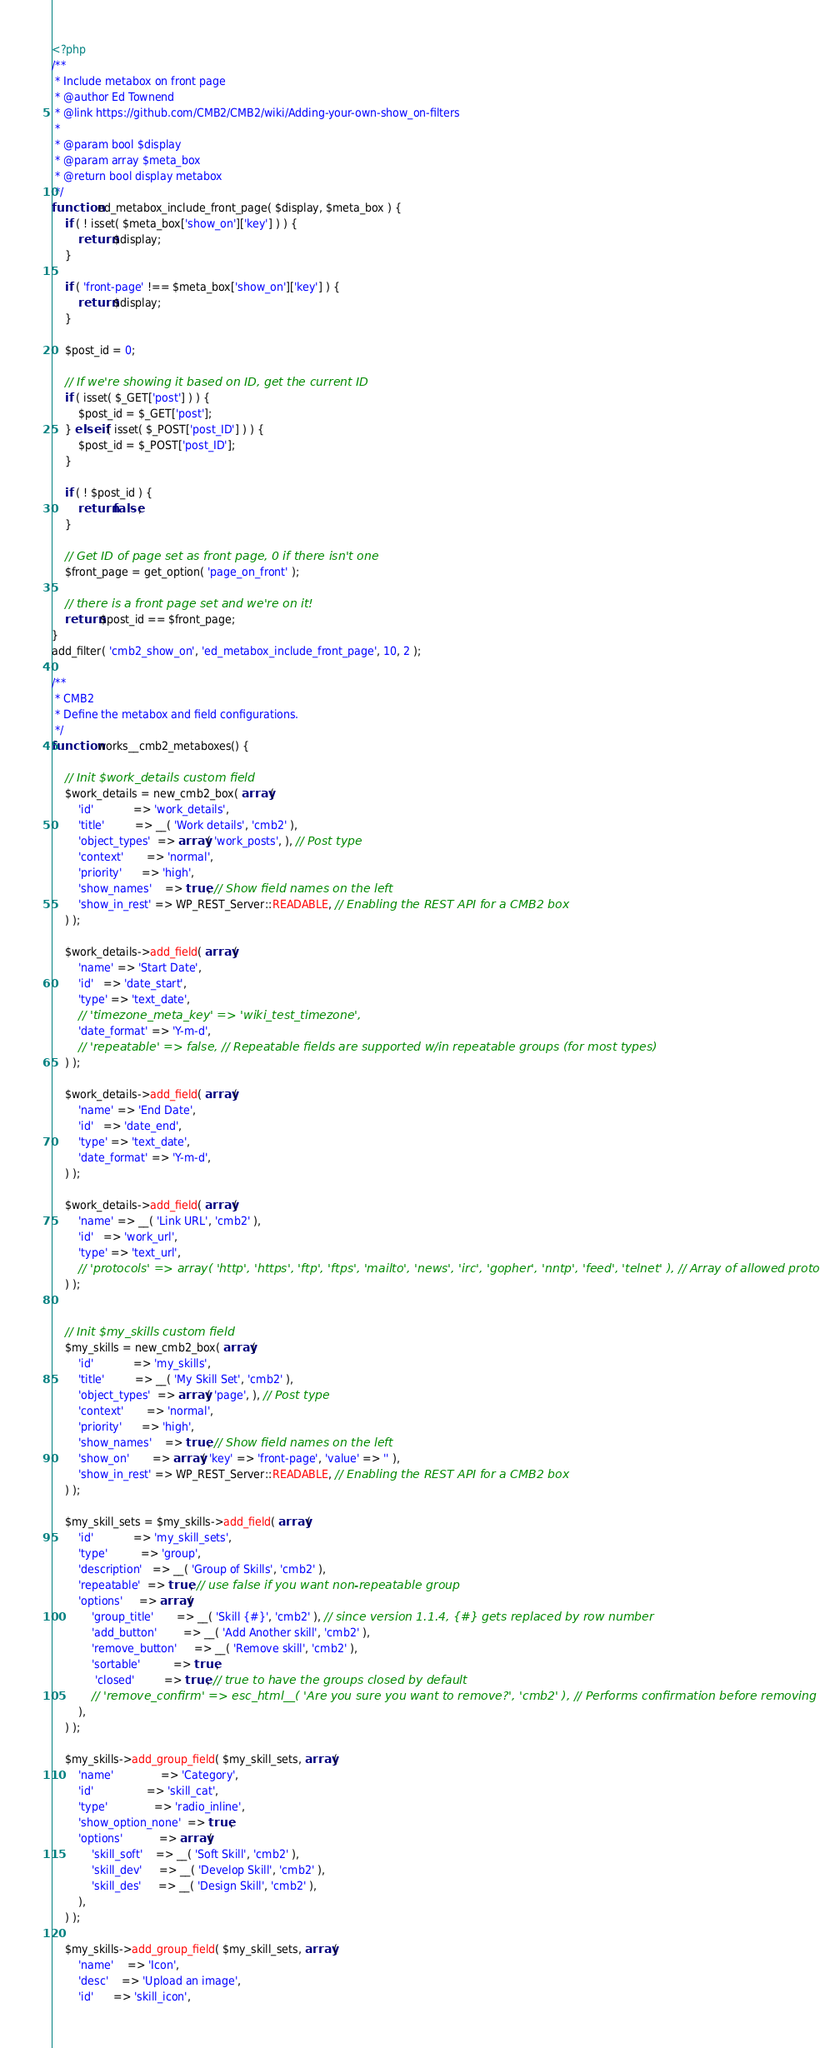<code> <loc_0><loc_0><loc_500><loc_500><_PHP_><?php
/**
 * Include metabox on front page
 * @author Ed Townend
 * @link https://github.com/CMB2/CMB2/wiki/Adding-your-own-show_on-filters
 *
 * @param bool $display
 * @param array $meta_box
 * @return bool display metabox
 */
function ed_metabox_include_front_page( $display, $meta_box ) {
	if ( ! isset( $meta_box['show_on']['key'] ) ) {
		return $display;
	}

	if ( 'front-page' !== $meta_box['show_on']['key'] ) {
		return $display;
	}

	$post_id = 0;

	// If we're showing it based on ID, get the current ID
	if ( isset( $_GET['post'] ) ) {
		$post_id = $_GET['post'];
	} elseif ( isset( $_POST['post_ID'] ) ) {
		$post_id = $_POST['post_ID'];
	}

	if ( ! $post_id ) {
		return false;
	}

	// Get ID of page set as front page, 0 if there isn't one
	$front_page = get_option( 'page_on_front' );

	// there is a front page set and we're on it!
	return $post_id == $front_page;
}
add_filter( 'cmb2_show_on', 'ed_metabox_include_front_page', 10, 2 );

/**
 * CMB2
 * Define the metabox and field configurations.
 */
function works__cmb2_metaboxes() {

	// Init $work_details custom field
	$work_details = new_cmb2_box( array(
		'id'            => 'work_details',
		'title'         => __( 'Work details', 'cmb2' ),
		'object_types'  => array( 'work_posts', ), // Post type
		'context'       => 'normal',
		'priority'      => 'high',
		'show_names'    => true, // Show field names on the left
		'show_in_rest' => WP_REST_Server::READABLE, // Enabling the REST API for a CMB2 box
	) );

	$work_details->add_field( array(
		'name' => 'Start Date',
		'id'   => 'date_start',
		'type' => 'text_date',
		// 'timezone_meta_key' => 'wiki_test_timezone',
		'date_format' => 'Y-m-d',
		// 'repeatable' => false, // Repeatable fields are supported w/in repeatable groups (for most types)
	) );

	$work_details->add_field( array(
		'name' => 'End Date',
		'id'   => 'date_end',
		'type' => 'text_date',
		'date_format' => 'Y-m-d',
	) );

	$work_details->add_field( array(
		'name' => __( 'Link URL', 'cmb2' ),
		'id'   => 'work_url',
		'type' => 'text_url',
		// 'protocols' => array( 'http', 'https', 'ftp', 'ftps', 'mailto', 'news', 'irc', 'gopher', 'nntp', 'feed', 'telnet' ), // Array of allowed protocols
	) );


	// Init $my_skills custom field
	$my_skills = new_cmb2_box( array(
		'id'            => 'my_skills',
		'title'         => __( 'My Skill Set', 'cmb2' ),
		'object_types'  => array( 'page', ), // Post type
		'context'       => 'normal',
		'priority'      => 'high',
		'show_names'    => true, // Show field names on the left
		'show_on'       => array( 'key' => 'front-page', 'value' => '' ),
		'show_in_rest' => WP_REST_Server::READABLE, // Enabling the REST API for a CMB2 box
	) );

	$my_skill_sets = $my_skills->add_field( array(
		'id'            => 'my_skill_sets',
		'type'          => 'group',
		'description'   => __( 'Group of Skills', 'cmb2' ),
		'repeatable'  => true, // use false if you want non-repeatable group
		'options'     => array(
			'group_title'       => __( 'Skill {#}', 'cmb2' ), // since version 1.1.4, {#} gets replaced by row number
			'add_button'        => __( 'Add Another skill', 'cmb2' ),
			'remove_button'     => __( 'Remove skill', 'cmb2' ),
			'sortable'          => true,
			 'closed'         => true, // true to have the groups closed by default
			// 'remove_confirm' => esc_html__( 'Are you sure you want to remove?', 'cmb2' ), // Performs confirmation before removing group.
		),
	) );

	$my_skills->add_group_field( $my_skill_sets, array(
		'name'              => 'Category',
		'id'                => 'skill_cat',
		'type'              => 'radio_inline',
		'show_option_none'  => true,
		'options'           => array(
			'skill_soft'    => __( 'Soft Skill', 'cmb2' ),
			'skill_dev'     => __( 'Develop Skill', 'cmb2' ),
			'skill_des'     => __( 'Design Skill', 'cmb2' ),
		),
	) );

	$my_skills->add_group_field( $my_skill_sets, array(
		'name'    => 'Icon',
		'desc'    => 'Upload an image',
		'id'      => 'skill_icon',</code> 